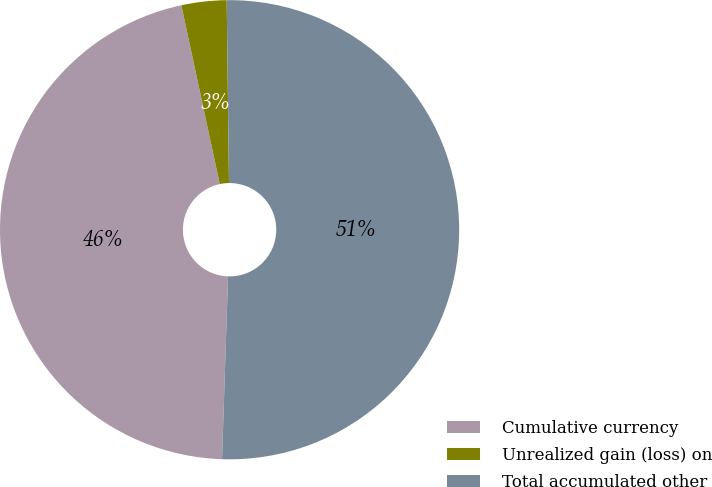Convert chart. <chart><loc_0><loc_0><loc_500><loc_500><pie_chart><fcel>Cumulative currency<fcel>Unrealized gain (loss) on<fcel>Total accumulated other<nl><fcel>46.11%<fcel>3.17%<fcel>50.72%<nl></chart> 